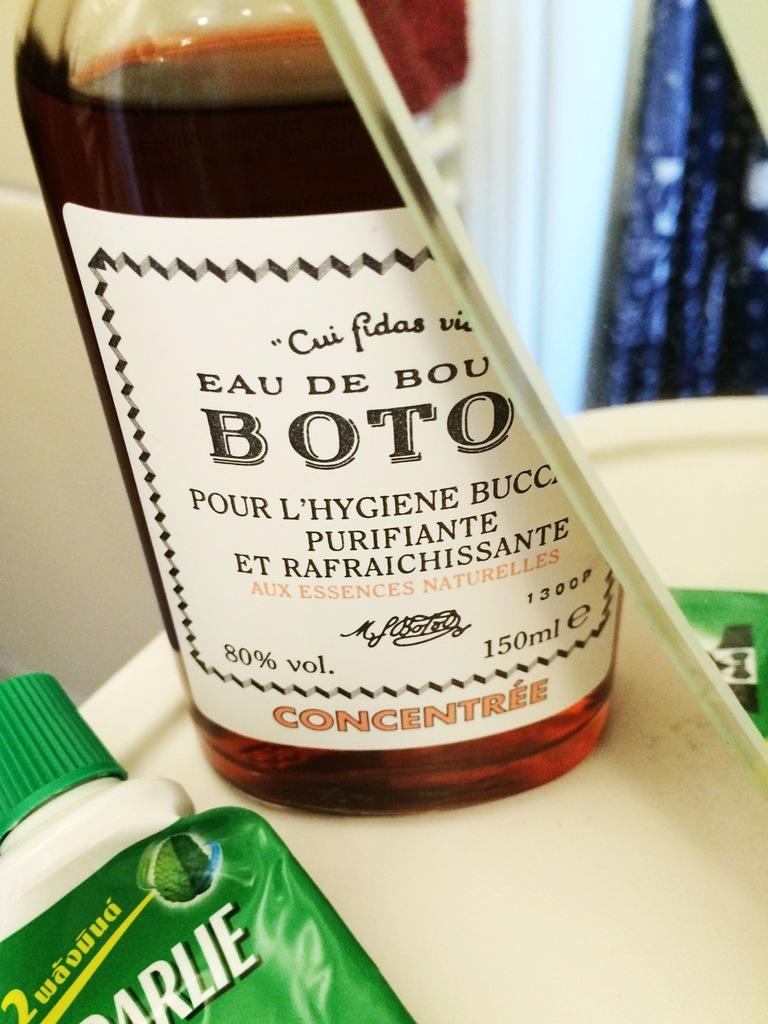What is on the bottle in the image? There is a sticker on the bottle in the image. What is inside the bottle? The bottle is filled with a drink. On what surface is the bottle placed? The bottle is on a white-colored table. What is near the table in the image? There is a mirror near the table and another bottle near the table. What is the color of the background in the image? The background of the image is white in color. What type of verse can be seen written on the sticker of the bottle? There is no verse written on the sticker of the bottle in the image. What type of meat is being served on the white-colored table? There is no meat present in the image; it only features a bottle with a sticker, another bottle, and a mirror near a white table. 